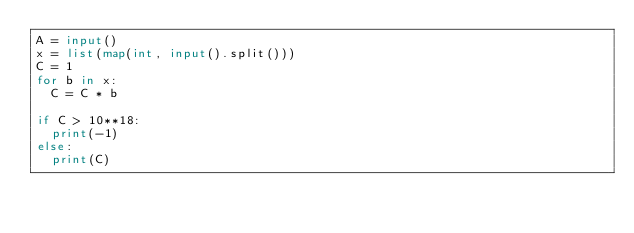Convert code to text. <code><loc_0><loc_0><loc_500><loc_500><_Python_>A = input()
x = list(map(int, input().split()))
C = 1
for b in x:
  C = C * b

if C > 10**18:
  print(-1)
else:
  print(C)

  </code> 